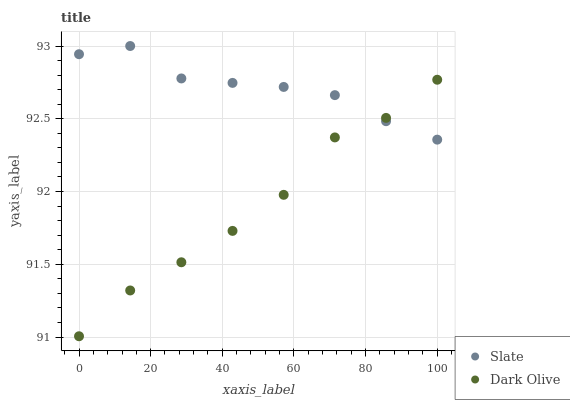Does Dark Olive have the minimum area under the curve?
Answer yes or no. Yes. Does Slate have the maximum area under the curve?
Answer yes or no. Yes. Does Dark Olive have the maximum area under the curve?
Answer yes or no. No. Is Slate the smoothest?
Answer yes or no. Yes. Is Dark Olive the roughest?
Answer yes or no. Yes. Is Dark Olive the smoothest?
Answer yes or no. No. Does Dark Olive have the lowest value?
Answer yes or no. Yes. Does Slate have the highest value?
Answer yes or no. Yes. Does Dark Olive have the highest value?
Answer yes or no. No. Does Dark Olive intersect Slate?
Answer yes or no. Yes. Is Dark Olive less than Slate?
Answer yes or no. No. Is Dark Olive greater than Slate?
Answer yes or no. No. 